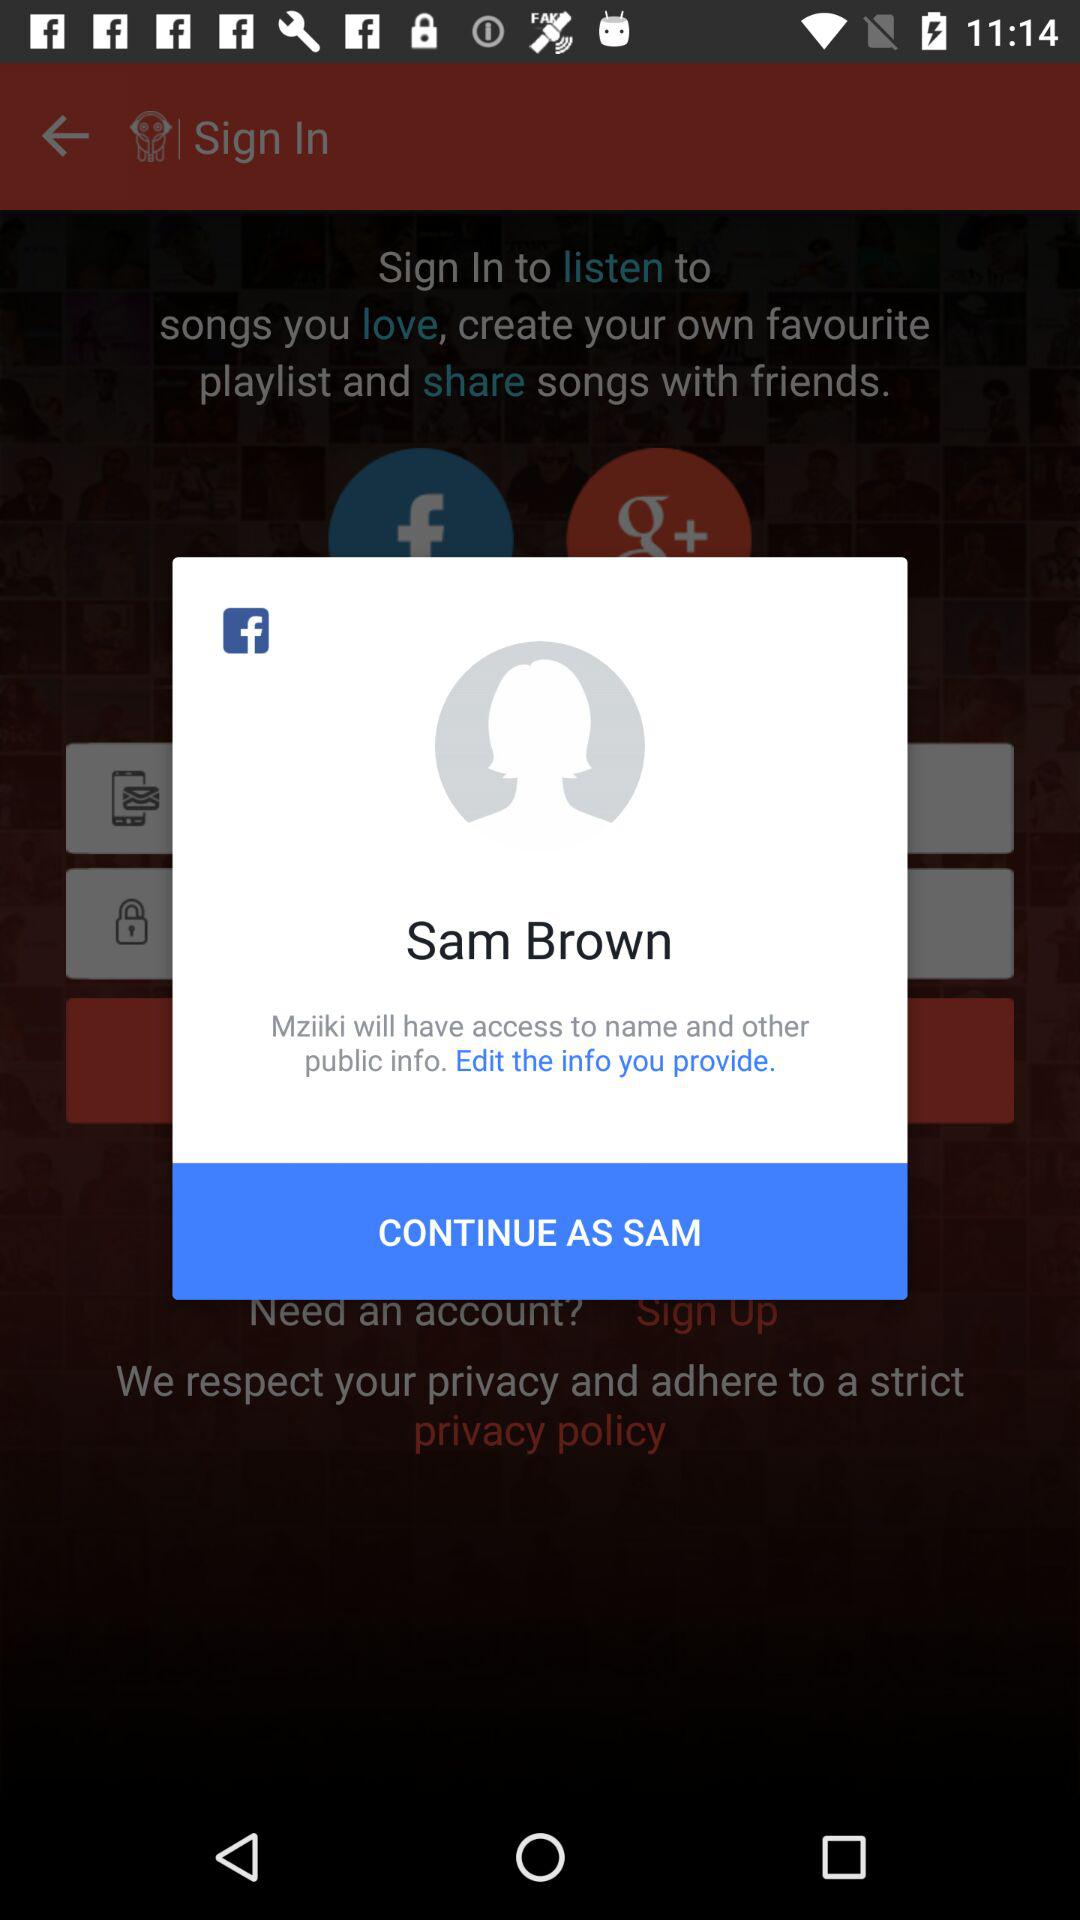What is the name of the user? The name of the user is Sam Brown. 